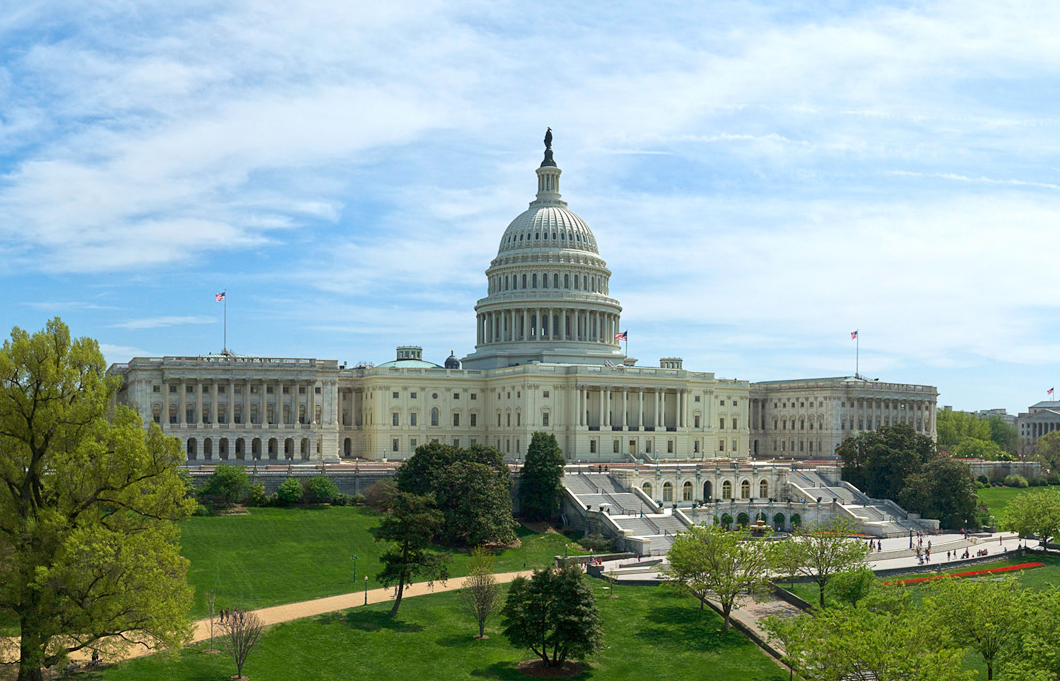Can you describe the main features of this image for me? The image showcases the United States Capitol in Washington, D.C., a quintessential example of American neoclassical architecture. The Capitol features a prominent white dome topped with the Statue of Freedom, flanked by expansive wings. The East Front, visible here, includes famous steps where presidential inaugurations take place. Amidst a clear day, the vibrant greenery of the Capitol grounds contrasts with the pure whiteness of the building, accentuated by visitors wandering the paths and relaxing on the lawns, offering a glimpse into daily life at this pivotal political landmark. 